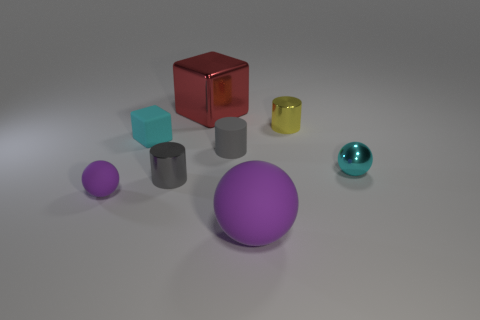What is the shape of the tiny thing that is the same color as the large matte thing?
Ensure brevity in your answer.  Sphere. There is a large thing that is in front of the tiny purple rubber ball; does it have the same shape as the matte thing behind the gray matte cylinder?
Your answer should be very brief. No. What number of things are either shiny things or small things that are in front of the tiny cyan rubber block?
Provide a succinct answer. 6. What is the material of the thing that is both right of the large purple sphere and in front of the gray matte object?
Offer a terse response. Metal. Is there anything else that has the same shape as the small cyan metallic thing?
Provide a succinct answer. Yes. What is the color of the large thing that is made of the same material as the tiny purple thing?
Ensure brevity in your answer.  Purple. How many things are small cyan cubes or matte things?
Your answer should be very brief. 4. There is a cyan rubber block; does it have the same size as the metal object that is to the right of the yellow cylinder?
Your answer should be very brief. Yes. What is the color of the small shiny thing behind the small cyan thing that is behind the tiny ball that is on the right side of the gray matte cylinder?
Ensure brevity in your answer.  Yellow. The matte block is what color?
Your answer should be very brief. Cyan. 